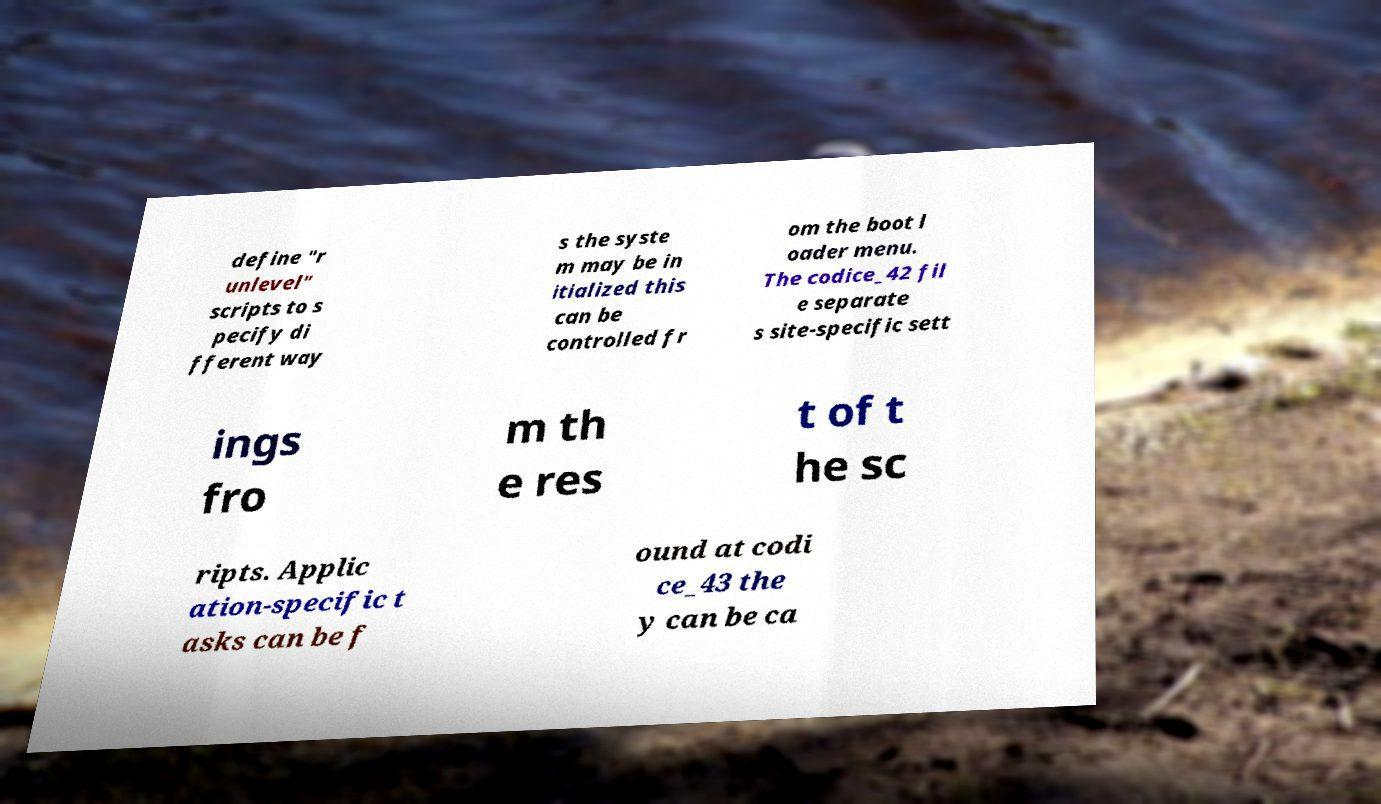What messages or text are displayed in this image? I need them in a readable, typed format. define "r unlevel" scripts to s pecify di fferent way s the syste m may be in itialized this can be controlled fr om the boot l oader menu. The codice_42 fil e separate s site-specific sett ings fro m th e res t of t he sc ripts. Applic ation-specific t asks can be f ound at codi ce_43 the y can be ca 